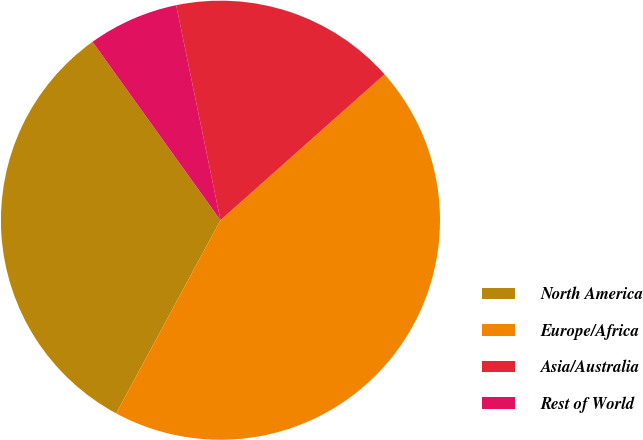<chart> <loc_0><loc_0><loc_500><loc_500><pie_chart><fcel>North America<fcel>Europe/Africa<fcel>Asia/Australia<fcel>Rest of World<nl><fcel>32.22%<fcel>44.44%<fcel>16.67%<fcel>6.67%<nl></chart> 